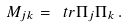<formula> <loc_0><loc_0><loc_500><loc_500>M _ { j k } = \ t r { \Pi _ { j } \Pi _ { k } } \, .</formula> 